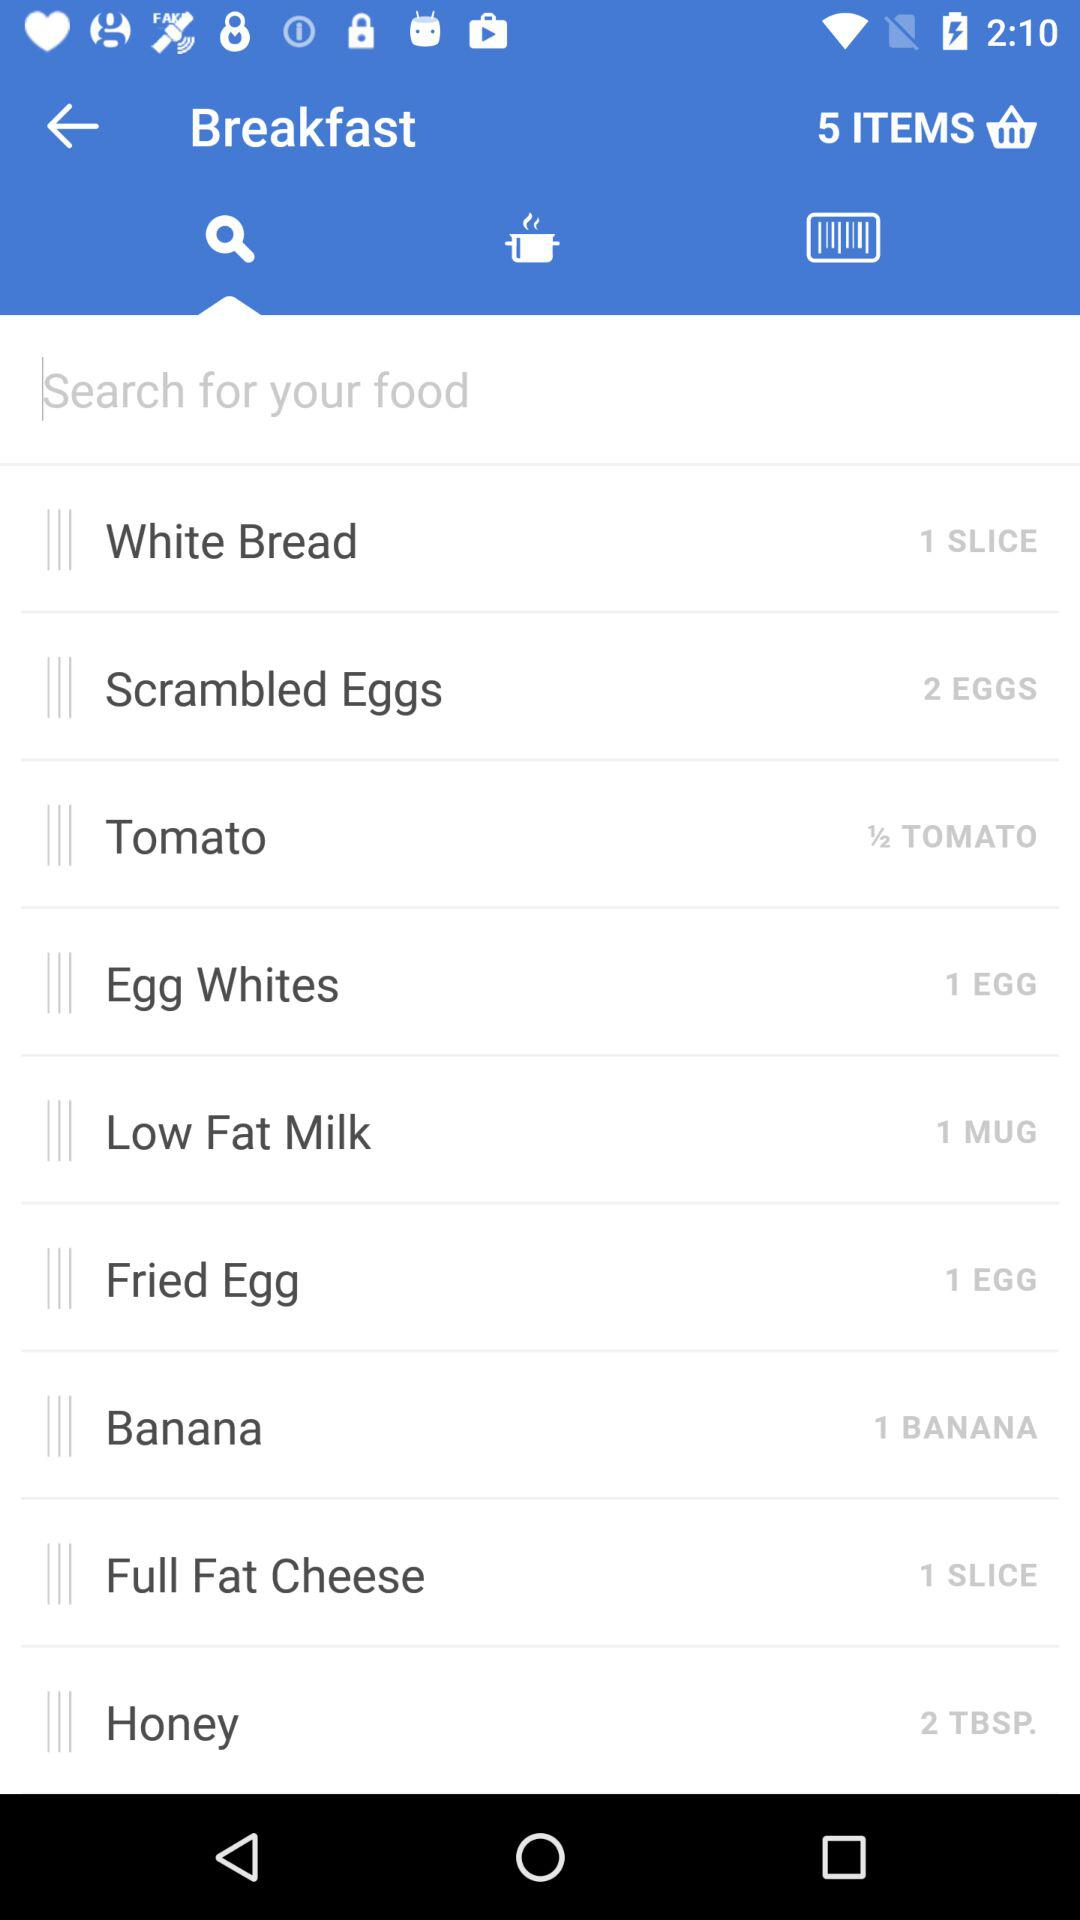How many eggs are required for the "Fried Egg" in "Breakfast"? The required number of eggs is 1. 